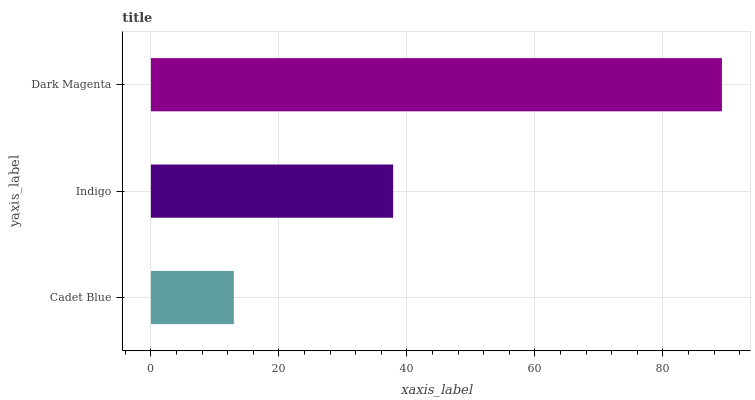Is Cadet Blue the minimum?
Answer yes or no. Yes. Is Dark Magenta the maximum?
Answer yes or no. Yes. Is Indigo the minimum?
Answer yes or no. No. Is Indigo the maximum?
Answer yes or no. No. Is Indigo greater than Cadet Blue?
Answer yes or no. Yes. Is Cadet Blue less than Indigo?
Answer yes or no. Yes. Is Cadet Blue greater than Indigo?
Answer yes or no. No. Is Indigo less than Cadet Blue?
Answer yes or no. No. Is Indigo the high median?
Answer yes or no. Yes. Is Indigo the low median?
Answer yes or no. Yes. Is Cadet Blue the high median?
Answer yes or no. No. Is Cadet Blue the low median?
Answer yes or no. No. 